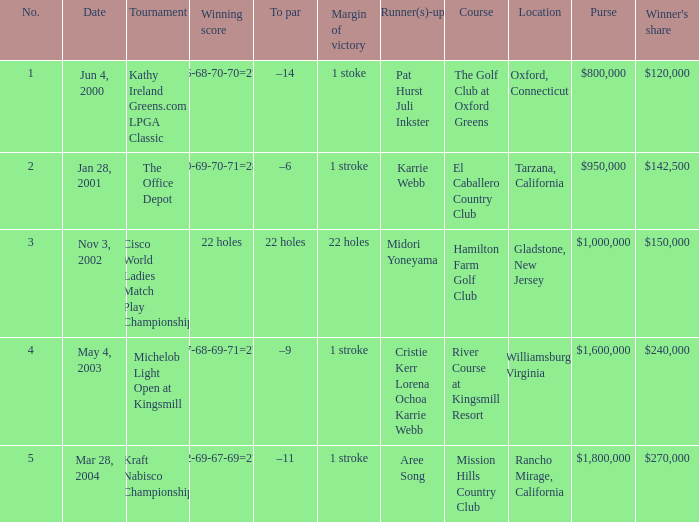What is the to par dated may 4, 2003? –9. 